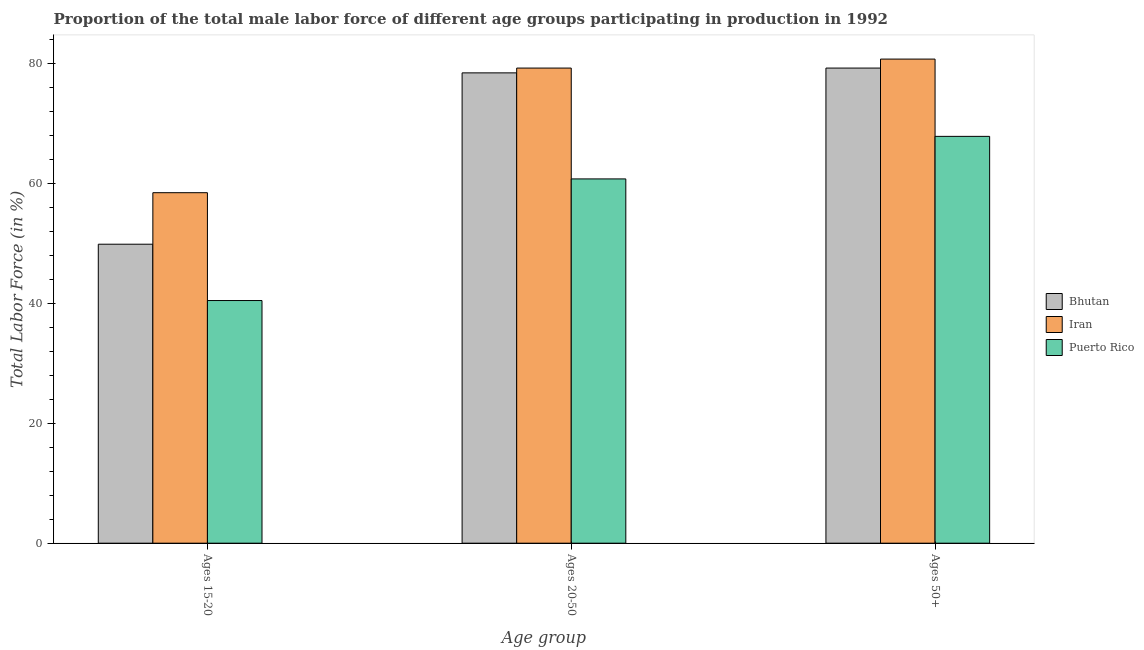How many different coloured bars are there?
Offer a terse response. 3. How many groups of bars are there?
Provide a succinct answer. 3. Are the number of bars per tick equal to the number of legend labels?
Provide a short and direct response. Yes. Are the number of bars on each tick of the X-axis equal?
Provide a succinct answer. Yes. How many bars are there on the 2nd tick from the left?
Ensure brevity in your answer.  3. How many bars are there on the 1st tick from the right?
Provide a short and direct response. 3. What is the label of the 3rd group of bars from the left?
Keep it short and to the point. Ages 50+. What is the percentage of male labor force above age 50 in Iran?
Your response must be concise. 80.8. Across all countries, what is the maximum percentage of male labor force within the age group 20-50?
Offer a terse response. 79.3. Across all countries, what is the minimum percentage of male labor force within the age group 15-20?
Keep it short and to the point. 40.5. In which country was the percentage of male labor force within the age group 20-50 maximum?
Your answer should be compact. Iran. In which country was the percentage of male labor force within the age group 15-20 minimum?
Your answer should be very brief. Puerto Rico. What is the total percentage of male labor force within the age group 15-20 in the graph?
Your answer should be very brief. 148.9. What is the difference between the percentage of male labor force within the age group 15-20 in Iran and that in Bhutan?
Provide a short and direct response. 8.6. What is the difference between the percentage of male labor force within the age group 15-20 in Iran and the percentage of male labor force above age 50 in Bhutan?
Your response must be concise. -20.8. What is the average percentage of male labor force within the age group 15-20 per country?
Your answer should be very brief. 49.63. What is the difference between the percentage of male labor force within the age group 20-50 and percentage of male labor force within the age group 15-20 in Puerto Rico?
Provide a short and direct response. 20.3. What is the ratio of the percentage of male labor force within the age group 20-50 in Bhutan to that in Iran?
Make the answer very short. 0.99. Is the difference between the percentage of male labor force within the age group 20-50 in Puerto Rico and Iran greater than the difference between the percentage of male labor force within the age group 15-20 in Puerto Rico and Iran?
Offer a terse response. No. What is the difference between the highest and the second highest percentage of male labor force within the age group 15-20?
Provide a short and direct response. 8.6. What is the difference between the highest and the lowest percentage of male labor force above age 50?
Make the answer very short. 12.9. In how many countries, is the percentage of male labor force above age 50 greater than the average percentage of male labor force above age 50 taken over all countries?
Your answer should be compact. 2. What does the 3rd bar from the left in Ages 50+ represents?
Provide a succinct answer. Puerto Rico. What does the 3rd bar from the right in Ages 20-50 represents?
Offer a terse response. Bhutan. Are all the bars in the graph horizontal?
Provide a short and direct response. No. How many countries are there in the graph?
Offer a terse response. 3. Are the values on the major ticks of Y-axis written in scientific E-notation?
Your answer should be very brief. No. Does the graph contain any zero values?
Your answer should be compact. No. Does the graph contain grids?
Make the answer very short. No. Where does the legend appear in the graph?
Offer a terse response. Center right. How many legend labels are there?
Keep it short and to the point. 3. How are the legend labels stacked?
Make the answer very short. Vertical. What is the title of the graph?
Your response must be concise. Proportion of the total male labor force of different age groups participating in production in 1992. What is the label or title of the X-axis?
Your answer should be compact. Age group. What is the label or title of the Y-axis?
Your answer should be very brief. Total Labor Force (in %). What is the Total Labor Force (in %) of Bhutan in Ages 15-20?
Give a very brief answer. 49.9. What is the Total Labor Force (in %) in Iran in Ages 15-20?
Your response must be concise. 58.5. What is the Total Labor Force (in %) in Puerto Rico in Ages 15-20?
Offer a very short reply. 40.5. What is the Total Labor Force (in %) of Bhutan in Ages 20-50?
Provide a succinct answer. 78.5. What is the Total Labor Force (in %) of Iran in Ages 20-50?
Keep it short and to the point. 79.3. What is the Total Labor Force (in %) of Puerto Rico in Ages 20-50?
Keep it short and to the point. 60.8. What is the Total Labor Force (in %) in Bhutan in Ages 50+?
Your answer should be very brief. 79.3. What is the Total Labor Force (in %) in Iran in Ages 50+?
Offer a very short reply. 80.8. What is the Total Labor Force (in %) of Puerto Rico in Ages 50+?
Ensure brevity in your answer.  67.9. Across all Age group, what is the maximum Total Labor Force (in %) in Bhutan?
Offer a very short reply. 79.3. Across all Age group, what is the maximum Total Labor Force (in %) of Iran?
Provide a succinct answer. 80.8. Across all Age group, what is the maximum Total Labor Force (in %) of Puerto Rico?
Make the answer very short. 67.9. Across all Age group, what is the minimum Total Labor Force (in %) of Bhutan?
Provide a succinct answer. 49.9. Across all Age group, what is the minimum Total Labor Force (in %) in Iran?
Ensure brevity in your answer.  58.5. Across all Age group, what is the minimum Total Labor Force (in %) in Puerto Rico?
Your answer should be very brief. 40.5. What is the total Total Labor Force (in %) of Bhutan in the graph?
Offer a terse response. 207.7. What is the total Total Labor Force (in %) in Iran in the graph?
Ensure brevity in your answer.  218.6. What is the total Total Labor Force (in %) in Puerto Rico in the graph?
Make the answer very short. 169.2. What is the difference between the Total Labor Force (in %) of Bhutan in Ages 15-20 and that in Ages 20-50?
Keep it short and to the point. -28.6. What is the difference between the Total Labor Force (in %) of Iran in Ages 15-20 and that in Ages 20-50?
Offer a very short reply. -20.8. What is the difference between the Total Labor Force (in %) of Puerto Rico in Ages 15-20 and that in Ages 20-50?
Your answer should be very brief. -20.3. What is the difference between the Total Labor Force (in %) in Bhutan in Ages 15-20 and that in Ages 50+?
Keep it short and to the point. -29.4. What is the difference between the Total Labor Force (in %) of Iran in Ages 15-20 and that in Ages 50+?
Make the answer very short. -22.3. What is the difference between the Total Labor Force (in %) in Puerto Rico in Ages 15-20 and that in Ages 50+?
Provide a succinct answer. -27.4. What is the difference between the Total Labor Force (in %) in Iran in Ages 20-50 and that in Ages 50+?
Make the answer very short. -1.5. What is the difference between the Total Labor Force (in %) of Puerto Rico in Ages 20-50 and that in Ages 50+?
Make the answer very short. -7.1. What is the difference between the Total Labor Force (in %) in Bhutan in Ages 15-20 and the Total Labor Force (in %) in Iran in Ages 20-50?
Offer a terse response. -29.4. What is the difference between the Total Labor Force (in %) in Bhutan in Ages 15-20 and the Total Labor Force (in %) in Iran in Ages 50+?
Your answer should be very brief. -30.9. What is the difference between the Total Labor Force (in %) of Iran in Ages 15-20 and the Total Labor Force (in %) of Puerto Rico in Ages 50+?
Give a very brief answer. -9.4. What is the difference between the Total Labor Force (in %) in Bhutan in Ages 20-50 and the Total Labor Force (in %) in Puerto Rico in Ages 50+?
Offer a very short reply. 10.6. What is the difference between the Total Labor Force (in %) of Iran in Ages 20-50 and the Total Labor Force (in %) of Puerto Rico in Ages 50+?
Offer a very short reply. 11.4. What is the average Total Labor Force (in %) in Bhutan per Age group?
Your answer should be very brief. 69.23. What is the average Total Labor Force (in %) of Iran per Age group?
Provide a succinct answer. 72.87. What is the average Total Labor Force (in %) of Puerto Rico per Age group?
Your answer should be very brief. 56.4. What is the difference between the Total Labor Force (in %) in Bhutan and Total Labor Force (in %) in Iran in Ages 15-20?
Make the answer very short. -8.6. What is the difference between the Total Labor Force (in %) in Bhutan and Total Labor Force (in %) in Puerto Rico in Ages 15-20?
Your response must be concise. 9.4. What is the difference between the Total Labor Force (in %) of Bhutan and Total Labor Force (in %) of Puerto Rico in Ages 20-50?
Your answer should be very brief. 17.7. What is the difference between the Total Labor Force (in %) of Bhutan and Total Labor Force (in %) of Puerto Rico in Ages 50+?
Make the answer very short. 11.4. What is the ratio of the Total Labor Force (in %) of Bhutan in Ages 15-20 to that in Ages 20-50?
Your answer should be very brief. 0.64. What is the ratio of the Total Labor Force (in %) in Iran in Ages 15-20 to that in Ages 20-50?
Ensure brevity in your answer.  0.74. What is the ratio of the Total Labor Force (in %) of Puerto Rico in Ages 15-20 to that in Ages 20-50?
Ensure brevity in your answer.  0.67. What is the ratio of the Total Labor Force (in %) of Bhutan in Ages 15-20 to that in Ages 50+?
Your answer should be very brief. 0.63. What is the ratio of the Total Labor Force (in %) in Iran in Ages 15-20 to that in Ages 50+?
Offer a very short reply. 0.72. What is the ratio of the Total Labor Force (in %) in Puerto Rico in Ages 15-20 to that in Ages 50+?
Keep it short and to the point. 0.6. What is the ratio of the Total Labor Force (in %) in Iran in Ages 20-50 to that in Ages 50+?
Your response must be concise. 0.98. What is the ratio of the Total Labor Force (in %) of Puerto Rico in Ages 20-50 to that in Ages 50+?
Provide a succinct answer. 0.9. What is the difference between the highest and the second highest Total Labor Force (in %) in Bhutan?
Offer a terse response. 0.8. What is the difference between the highest and the lowest Total Labor Force (in %) of Bhutan?
Offer a terse response. 29.4. What is the difference between the highest and the lowest Total Labor Force (in %) of Iran?
Your answer should be compact. 22.3. What is the difference between the highest and the lowest Total Labor Force (in %) of Puerto Rico?
Make the answer very short. 27.4. 